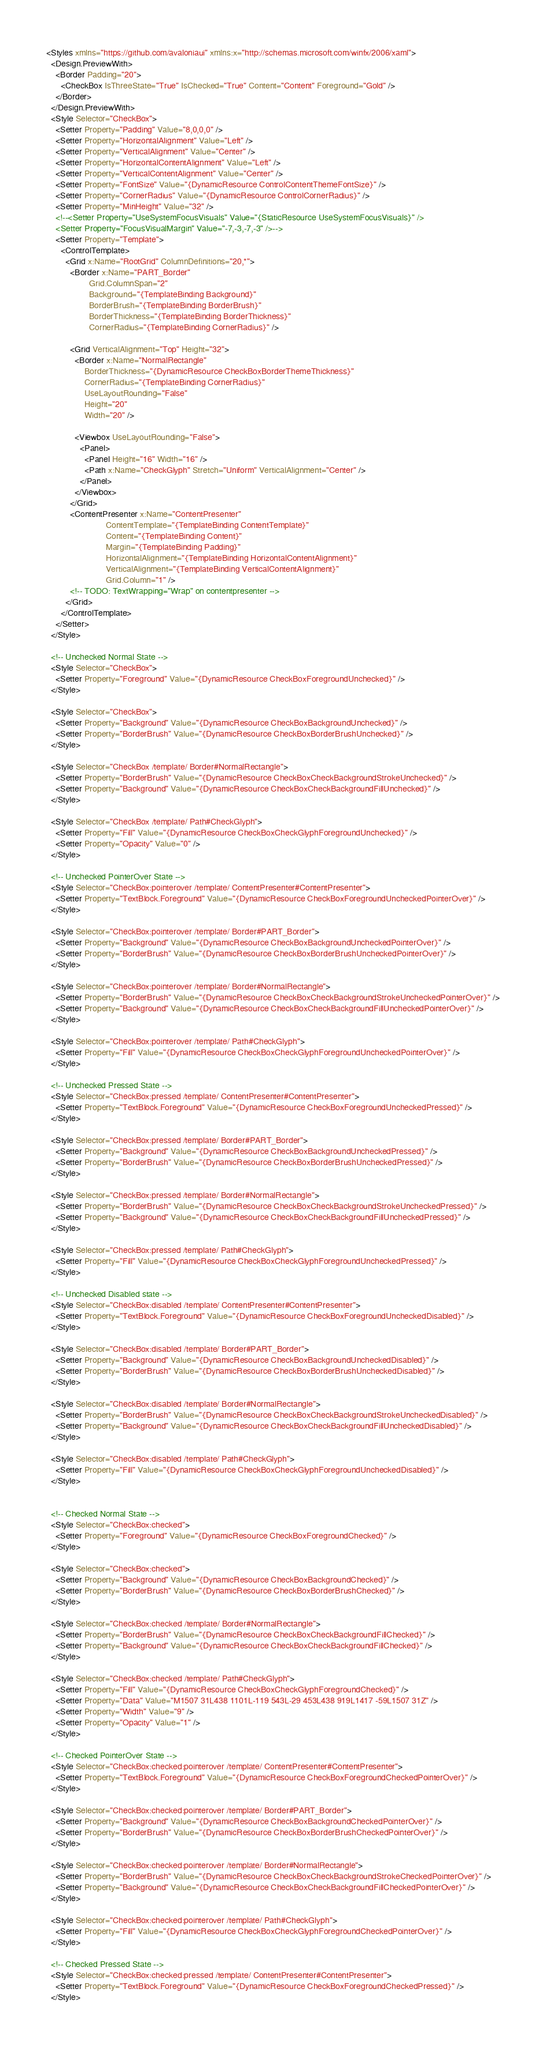<code> <loc_0><loc_0><loc_500><loc_500><_XML_><Styles xmlns="https://github.com/avaloniaui" xmlns:x="http://schemas.microsoft.com/winfx/2006/xaml">
  <Design.PreviewWith>
    <Border Padding="20">
      <CheckBox IsThreeState="True" IsChecked="True" Content="Content" Foreground="Gold" />
    </Border>
  </Design.PreviewWith>
  <Style Selector="CheckBox">
    <Setter Property="Padding" Value="8,0,0,0" />
    <Setter Property="HorizontalAlignment" Value="Left" />
    <Setter Property="VerticalAlignment" Value="Center" />
    <Setter Property="HorizontalContentAlignment" Value="Left" />
    <Setter Property="VerticalContentAlignment" Value="Center" />    
    <Setter Property="FontSize" Value="{DynamicResource ControlContentThemeFontSize}" />
    <Setter Property="CornerRadius" Value="{DynamicResource ControlCornerRadius}" />
    <Setter Property="MinHeight" Value="32" />
    <!--<Setter Property="UseSystemFocusVisuals" Value="{StaticResource UseSystemFocusVisuals}" />
    <Setter Property="FocusVisualMargin" Value="-7,-3,-7,-3" />-->
    <Setter Property="Template">
      <ControlTemplate>
        <Grid x:Name="RootGrid" ColumnDefinitions="20,*">
          <Border x:Name="PART_Border"
                  Grid.ColumnSpan="2"
                  Background="{TemplateBinding Background}"
                  BorderBrush="{TemplateBinding BorderBrush}"
                  BorderThickness="{TemplateBinding BorderThickness}"
                  CornerRadius="{TemplateBinding CornerRadius}" />

          <Grid VerticalAlignment="Top" Height="32">
            <Border x:Name="NormalRectangle"
                BorderThickness="{DynamicResource CheckBoxBorderThemeThickness}"
                CornerRadius="{TemplateBinding CornerRadius}"
                UseLayoutRounding="False"
                Height="20"
                Width="20" />

            <Viewbox UseLayoutRounding="False">
              <Panel>
                <Panel Height="16" Width="16" />
                <Path x:Name="CheckGlyph" Stretch="Uniform" VerticalAlignment="Center" />
              </Panel>
            </Viewbox>
          </Grid>
          <ContentPresenter x:Name="ContentPresenter"
                         ContentTemplate="{TemplateBinding ContentTemplate}"
                         Content="{TemplateBinding Content}"
                         Margin="{TemplateBinding Padding}"
                         HorizontalAlignment="{TemplateBinding HorizontalContentAlignment}"
                         VerticalAlignment="{TemplateBinding VerticalContentAlignment}"
                         Grid.Column="1" />
          <!-- TODO: TextWrapping="Wrap" on contentpresenter -->
        </Grid>
      </ControlTemplate>
    </Setter>
  </Style>

  <!-- Unchecked Normal State -->
  <Style Selector="CheckBox">
    <Setter Property="Foreground" Value="{DynamicResource CheckBoxForegroundUnchecked}" />
  </Style>

  <Style Selector="CheckBox">
    <Setter Property="Background" Value="{DynamicResource CheckBoxBackgroundUnchecked}" />
    <Setter Property="BorderBrush" Value="{DynamicResource CheckBoxBorderBrushUnchecked}" />
  </Style>

  <Style Selector="CheckBox /template/ Border#NormalRectangle">
    <Setter Property="BorderBrush" Value="{DynamicResource CheckBoxCheckBackgroundStrokeUnchecked}" />
    <Setter Property="Background" Value="{DynamicResource CheckBoxCheckBackgroundFillUnchecked}" />
  </Style>

  <Style Selector="CheckBox /template/ Path#CheckGlyph">
    <Setter Property="Fill" Value="{DynamicResource CheckBoxCheckGlyphForegroundUnchecked}" />
    <Setter Property="Opacity" Value="0" />
  </Style>

  <!-- Unchecked PointerOver State -->
  <Style Selector="CheckBox:pointerover /template/ ContentPresenter#ContentPresenter">
    <Setter Property="TextBlock.Foreground" Value="{DynamicResource CheckBoxForegroundUncheckedPointerOver}" />
  </Style>

  <Style Selector="CheckBox:pointerover /template/ Border#PART_Border">
    <Setter Property="Background" Value="{DynamicResource CheckBoxBackgroundUncheckedPointerOver}" />
    <Setter Property="BorderBrush" Value="{DynamicResource CheckBoxBorderBrushUncheckedPointerOver}" />
  </Style>

  <Style Selector="CheckBox:pointerover /template/ Border#NormalRectangle">
    <Setter Property="BorderBrush" Value="{DynamicResource CheckBoxCheckBackgroundStrokeUncheckedPointerOver}" />
    <Setter Property="Background" Value="{DynamicResource CheckBoxCheckBackgroundFillUncheckedPointerOver}" />
  </Style>

  <Style Selector="CheckBox:pointerover /template/ Path#CheckGlyph">
    <Setter Property="Fill" Value="{DynamicResource CheckBoxCheckGlyphForegroundUncheckedPointerOver}" />
  </Style>

  <!-- Unchecked Pressed State -->
  <Style Selector="CheckBox:pressed /template/ ContentPresenter#ContentPresenter">
    <Setter Property="TextBlock.Foreground" Value="{DynamicResource CheckBoxForegroundUncheckedPressed}" />
  </Style>

  <Style Selector="CheckBox:pressed /template/ Border#PART_Border">
    <Setter Property="Background" Value="{DynamicResource CheckBoxBackgroundUncheckedPressed}" />
    <Setter Property="BorderBrush" Value="{DynamicResource CheckBoxBorderBrushUncheckedPressed}" />
  </Style>

  <Style Selector="CheckBox:pressed /template/ Border#NormalRectangle">
    <Setter Property="BorderBrush" Value="{DynamicResource CheckBoxCheckBackgroundStrokeUncheckedPressed}" />
    <Setter Property="Background" Value="{DynamicResource CheckBoxCheckBackgroundFillUncheckedPressed}" />
  </Style>

  <Style Selector="CheckBox:pressed /template/ Path#CheckGlyph">
    <Setter Property="Fill" Value="{DynamicResource CheckBoxCheckGlyphForegroundUncheckedPressed}" />
  </Style>

  <!-- Unchecked Disabled state -->
  <Style Selector="CheckBox:disabled /template/ ContentPresenter#ContentPresenter">
    <Setter Property="TextBlock.Foreground" Value="{DynamicResource CheckBoxForegroundUncheckedDisabled}" />
  </Style>

  <Style Selector="CheckBox:disabled /template/ Border#PART_Border">
    <Setter Property="Background" Value="{DynamicResource CheckBoxBackgroundUncheckedDisabled}" />
    <Setter Property="BorderBrush" Value="{DynamicResource CheckBoxBorderBrushUncheckedDisabled}" />
  </Style>

  <Style Selector="CheckBox:disabled /template/ Border#NormalRectangle">
    <Setter Property="BorderBrush" Value="{DynamicResource CheckBoxCheckBackgroundStrokeUncheckedDisabled}" />
    <Setter Property="Background" Value="{DynamicResource CheckBoxCheckBackgroundFillUncheckedDisabled}" />
  </Style>

  <Style Selector="CheckBox:disabled /template/ Path#CheckGlyph">
    <Setter Property="Fill" Value="{DynamicResource CheckBoxCheckGlyphForegroundUncheckedDisabled}" />
  </Style>


  <!-- Checked Normal State -->
  <Style Selector="CheckBox:checked">
    <Setter Property="Foreground" Value="{DynamicResource CheckBoxForegroundChecked}" />
  </Style>

  <Style Selector="CheckBox:checked">
    <Setter Property="Background" Value="{DynamicResource CheckBoxBackgroundChecked}" />
    <Setter Property="BorderBrush" Value="{DynamicResource CheckBoxBorderBrushChecked}" />
  </Style>

  <Style Selector="CheckBox:checked /template/ Border#NormalRectangle">
    <Setter Property="BorderBrush" Value="{DynamicResource CheckBoxCheckBackgroundFillChecked}" />
    <Setter Property="Background" Value="{DynamicResource CheckBoxCheckBackgroundFillChecked}" />
  </Style>

  <Style Selector="CheckBox:checked /template/ Path#CheckGlyph">
    <Setter Property="Fill" Value="{DynamicResource CheckBoxCheckGlyphForegroundChecked}" />
    <Setter Property="Data" Value="M1507 31L438 1101L-119 543L-29 453L438 919L1417 -59L1507 31Z" />
    <Setter Property="Width" Value="9" />
    <Setter Property="Opacity" Value="1" />
  </Style>

  <!-- Checked PointerOver State -->
  <Style Selector="CheckBox:checked:pointerover /template/ ContentPresenter#ContentPresenter">
    <Setter Property="TextBlock.Foreground" Value="{DynamicResource CheckBoxForegroundCheckedPointerOver}" />
  </Style>

  <Style Selector="CheckBox:checked:pointerover /template/ Border#PART_Border">
    <Setter Property="Background" Value="{DynamicResource CheckBoxBackgroundCheckedPointerOver}" />
    <Setter Property="BorderBrush" Value="{DynamicResource CheckBoxBorderBrushCheckedPointerOver}" />
  </Style>

  <Style Selector="CheckBox:checked:pointerover /template/ Border#NormalRectangle">
    <Setter Property="BorderBrush" Value="{DynamicResource CheckBoxCheckBackgroundStrokeCheckedPointerOver}" />
    <Setter Property="Background" Value="{DynamicResource CheckBoxCheckBackgroundFillCheckedPointerOver}" />
  </Style>

  <Style Selector="CheckBox:checked:pointerover /template/ Path#CheckGlyph">
    <Setter Property="Fill" Value="{DynamicResource CheckBoxCheckGlyphForegroundCheckedPointerOver}" />
  </Style>

  <!-- Checked Pressed State -->
  <Style Selector="CheckBox:checked:pressed /template/ ContentPresenter#ContentPresenter">
    <Setter Property="TextBlock.Foreground" Value="{DynamicResource CheckBoxForegroundCheckedPressed}" />
  </Style>
</code> 